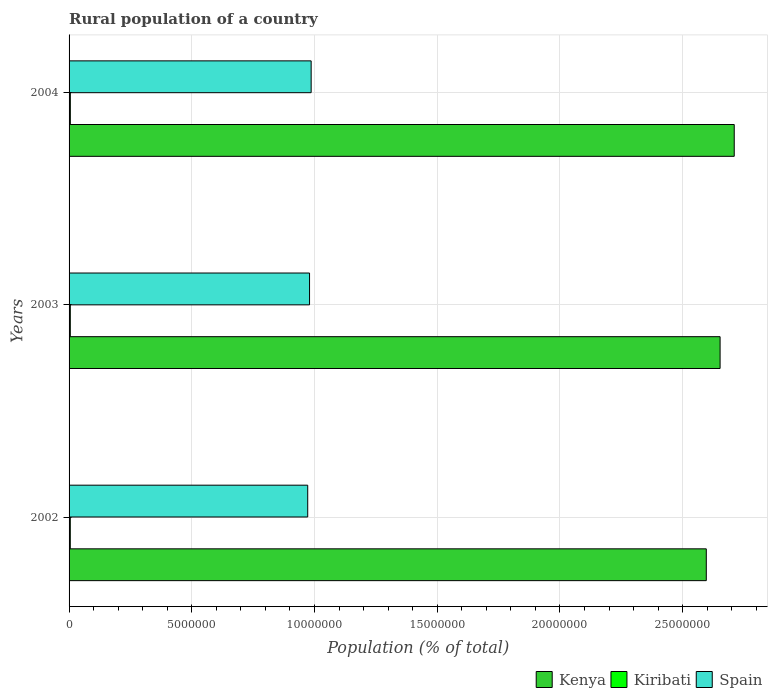Are the number of bars on each tick of the Y-axis equal?
Your answer should be compact. Yes. In how many cases, is the number of bars for a given year not equal to the number of legend labels?
Your answer should be very brief. 0. What is the rural population in Spain in 2003?
Offer a very short reply. 9.80e+06. Across all years, what is the maximum rural population in Kiribati?
Give a very brief answer. 5.11e+04. Across all years, what is the minimum rural population in Kenya?
Your answer should be very brief. 2.60e+07. In which year was the rural population in Kiribati maximum?
Offer a very short reply. 2004. In which year was the rural population in Kenya minimum?
Provide a succinct answer. 2002. What is the total rural population in Kiribati in the graph?
Your response must be concise. 1.51e+05. What is the difference between the rural population in Kenya in 2002 and that in 2003?
Offer a terse response. -5.62e+05. What is the difference between the rural population in Kiribati in 2003 and the rural population in Kenya in 2002?
Ensure brevity in your answer.  -2.59e+07. What is the average rural population in Kenya per year?
Your answer should be compact. 2.65e+07. In the year 2003, what is the difference between the rural population in Kiribati and rural population in Spain?
Provide a short and direct response. -9.75e+06. What is the ratio of the rural population in Spain in 2002 to that in 2003?
Your answer should be compact. 0.99. What is the difference between the highest and the second highest rural population in Kenya?
Make the answer very short. 5.76e+05. What is the difference between the highest and the lowest rural population in Kenya?
Offer a terse response. 1.14e+06. In how many years, is the rural population in Kiribati greater than the average rural population in Kiribati taken over all years?
Your response must be concise. 1. What does the 1st bar from the bottom in 2003 represents?
Provide a short and direct response. Kenya. Is it the case that in every year, the sum of the rural population in Kenya and rural population in Kiribati is greater than the rural population in Spain?
Your answer should be very brief. Yes. How many bars are there?
Your answer should be very brief. 9. Are all the bars in the graph horizontal?
Offer a terse response. Yes. How many years are there in the graph?
Your answer should be very brief. 3. Are the values on the major ticks of X-axis written in scientific E-notation?
Make the answer very short. No. Where does the legend appear in the graph?
Give a very brief answer. Bottom right. How many legend labels are there?
Provide a short and direct response. 3. What is the title of the graph?
Offer a very short reply. Rural population of a country. What is the label or title of the X-axis?
Your answer should be compact. Population (% of total). What is the label or title of the Y-axis?
Offer a very short reply. Years. What is the Population (% of total) of Kenya in 2002?
Your response must be concise. 2.60e+07. What is the Population (% of total) in Kiribati in 2002?
Your response must be concise. 4.94e+04. What is the Population (% of total) of Spain in 2002?
Give a very brief answer. 9.72e+06. What is the Population (% of total) of Kenya in 2003?
Keep it short and to the point. 2.65e+07. What is the Population (% of total) of Kiribati in 2003?
Your answer should be compact. 5.02e+04. What is the Population (% of total) in Spain in 2003?
Give a very brief answer. 9.80e+06. What is the Population (% of total) in Kenya in 2004?
Provide a succinct answer. 2.71e+07. What is the Population (% of total) of Kiribati in 2004?
Your answer should be compact. 5.11e+04. What is the Population (% of total) in Spain in 2004?
Your answer should be compact. 9.86e+06. Across all years, what is the maximum Population (% of total) in Kenya?
Provide a succinct answer. 2.71e+07. Across all years, what is the maximum Population (% of total) in Kiribati?
Your response must be concise. 5.11e+04. Across all years, what is the maximum Population (% of total) of Spain?
Make the answer very short. 9.86e+06. Across all years, what is the minimum Population (% of total) in Kenya?
Give a very brief answer. 2.60e+07. Across all years, what is the minimum Population (% of total) of Kiribati?
Give a very brief answer. 4.94e+04. Across all years, what is the minimum Population (% of total) in Spain?
Ensure brevity in your answer.  9.72e+06. What is the total Population (% of total) of Kenya in the graph?
Your answer should be compact. 7.96e+07. What is the total Population (% of total) in Kiribati in the graph?
Offer a terse response. 1.51e+05. What is the total Population (% of total) in Spain in the graph?
Your response must be concise. 2.94e+07. What is the difference between the Population (% of total) of Kenya in 2002 and that in 2003?
Your response must be concise. -5.62e+05. What is the difference between the Population (% of total) of Kiribati in 2002 and that in 2003?
Your answer should be compact. -857. What is the difference between the Population (% of total) in Spain in 2002 and that in 2003?
Your response must be concise. -7.41e+04. What is the difference between the Population (% of total) in Kenya in 2002 and that in 2004?
Your answer should be very brief. -1.14e+06. What is the difference between the Population (% of total) of Kiribati in 2002 and that in 2004?
Give a very brief answer. -1773. What is the difference between the Population (% of total) in Spain in 2002 and that in 2004?
Provide a short and direct response. -1.40e+05. What is the difference between the Population (% of total) in Kenya in 2003 and that in 2004?
Offer a terse response. -5.76e+05. What is the difference between the Population (% of total) of Kiribati in 2003 and that in 2004?
Provide a succinct answer. -916. What is the difference between the Population (% of total) in Spain in 2003 and that in 2004?
Keep it short and to the point. -6.58e+04. What is the difference between the Population (% of total) of Kenya in 2002 and the Population (% of total) of Kiribati in 2003?
Your response must be concise. 2.59e+07. What is the difference between the Population (% of total) in Kenya in 2002 and the Population (% of total) in Spain in 2003?
Offer a terse response. 1.62e+07. What is the difference between the Population (% of total) of Kiribati in 2002 and the Population (% of total) of Spain in 2003?
Make the answer very short. -9.75e+06. What is the difference between the Population (% of total) of Kenya in 2002 and the Population (% of total) of Kiribati in 2004?
Ensure brevity in your answer.  2.59e+07. What is the difference between the Population (% of total) in Kenya in 2002 and the Population (% of total) in Spain in 2004?
Provide a succinct answer. 1.61e+07. What is the difference between the Population (% of total) in Kiribati in 2002 and the Population (% of total) in Spain in 2004?
Provide a short and direct response. -9.81e+06. What is the difference between the Population (% of total) of Kenya in 2003 and the Population (% of total) of Kiribati in 2004?
Make the answer very short. 2.65e+07. What is the difference between the Population (% of total) in Kenya in 2003 and the Population (% of total) in Spain in 2004?
Make the answer very short. 1.67e+07. What is the difference between the Population (% of total) in Kiribati in 2003 and the Population (% of total) in Spain in 2004?
Your answer should be compact. -9.81e+06. What is the average Population (% of total) of Kenya per year?
Ensure brevity in your answer.  2.65e+07. What is the average Population (% of total) in Kiribati per year?
Make the answer very short. 5.02e+04. What is the average Population (% of total) of Spain per year?
Provide a succinct answer. 9.79e+06. In the year 2002, what is the difference between the Population (% of total) of Kenya and Population (% of total) of Kiribati?
Ensure brevity in your answer.  2.59e+07. In the year 2002, what is the difference between the Population (% of total) of Kenya and Population (% of total) of Spain?
Ensure brevity in your answer.  1.62e+07. In the year 2002, what is the difference between the Population (% of total) of Kiribati and Population (% of total) of Spain?
Offer a terse response. -9.67e+06. In the year 2003, what is the difference between the Population (% of total) of Kenya and Population (% of total) of Kiribati?
Keep it short and to the point. 2.65e+07. In the year 2003, what is the difference between the Population (% of total) of Kenya and Population (% of total) of Spain?
Give a very brief answer. 1.67e+07. In the year 2003, what is the difference between the Population (% of total) in Kiribati and Population (% of total) in Spain?
Provide a short and direct response. -9.75e+06. In the year 2004, what is the difference between the Population (% of total) in Kenya and Population (% of total) in Kiribati?
Your answer should be compact. 2.70e+07. In the year 2004, what is the difference between the Population (% of total) of Kenya and Population (% of total) of Spain?
Your response must be concise. 1.72e+07. In the year 2004, what is the difference between the Population (% of total) of Kiribati and Population (% of total) of Spain?
Your response must be concise. -9.81e+06. What is the ratio of the Population (% of total) of Kenya in 2002 to that in 2003?
Give a very brief answer. 0.98. What is the ratio of the Population (% of total) of Kiribati in 2002 to that in 2003?
Provide a succinct answer. 0.98. What is the ratio of the Population (% of total) in Spain in 2002 to that in 2003?
Offer a very short reply. 0.99. What is the ratio of the Population (% of total) of Kenya in 2002 to that in 2004?
Keep it short and to the point. 0.96. What is the ratio of the Population (% of total) of Kiribati in 2002 to that in 2004?
Offer a very short reply. 0.97. What is the ratio of the Population (% of total) of Spain in 2002 to that in 2004?
Offer a terse response. 0.99. What is the ratio of the Population (% of total) of Kenya in 2003 to that in 2004?
Your answer should be very brief. 0.98. What is the ratio of the Population (% of total) in Kiribati in 2003 to that in 2004?
Offer a terse response. 0.98. What is the difference between the highest and the second highest Population (% of total) in Kenya?
Your answer should be compact. 5.76e+05. What is the difference between the highest and the second highest Population (% of total) in Kiribati?
Your answer should be very brief. 916. What is the difference between the highest and the second highest Population (% of total) in Spain?
Your answer should be compact. 6.58e+04. What is the difference between the highest and the lowest Population (% of total) in Kenya?
Give a very brief answer. 1.14e+06. What is the difference between the highest and the lowest Population (% of total) in Kiribati?
Provide a succinct answer. 1773. What is the difference between the highest and the lowest Population (% of total) in Spain?
Your response must be concise. 1.40e+05. 